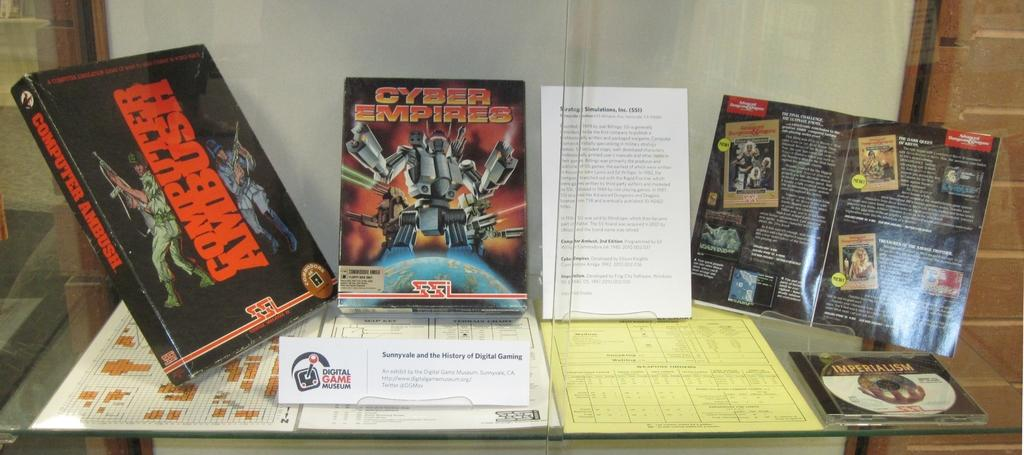<image>
Offer a succinct explanation of the picture presented. A book titled Computer Ambush set up to the left of some other books. 